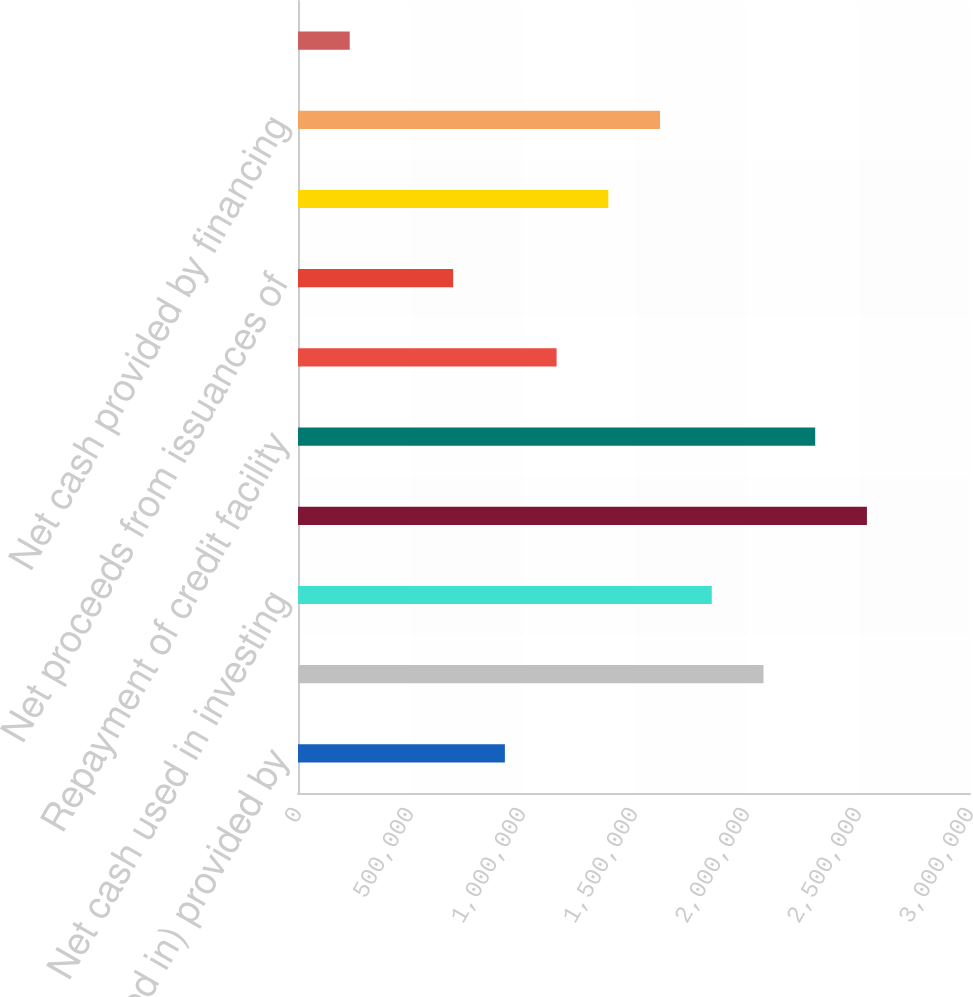Convert chart. <chart><loc_0><loc_0><loc_500><loc_500><bar_chart><fcel>Net cash (used in) provided by<fcel>Net cash paid for corporate<fcel>Net cash used in investing<fcel>Credit facility and<fcel>Repayment of credit facility<fcel>Purchase of treasury shares<fcel>Net proceeds from issuances of<fcel>Dividends paid<fcel>Net cash provided by financing<fcel>Increase (decrease) in cash<nl><fcel>923612<fcel>2.0781e+06<fcel>1.8472e+06<fcel>2.5399e+06<fcel>2.309e+06<fcel>1.15451e+06<fcel>692714<fcel>1.38541e+06<fcel>1.61631e+06<fcel>230918<nl></chart> 